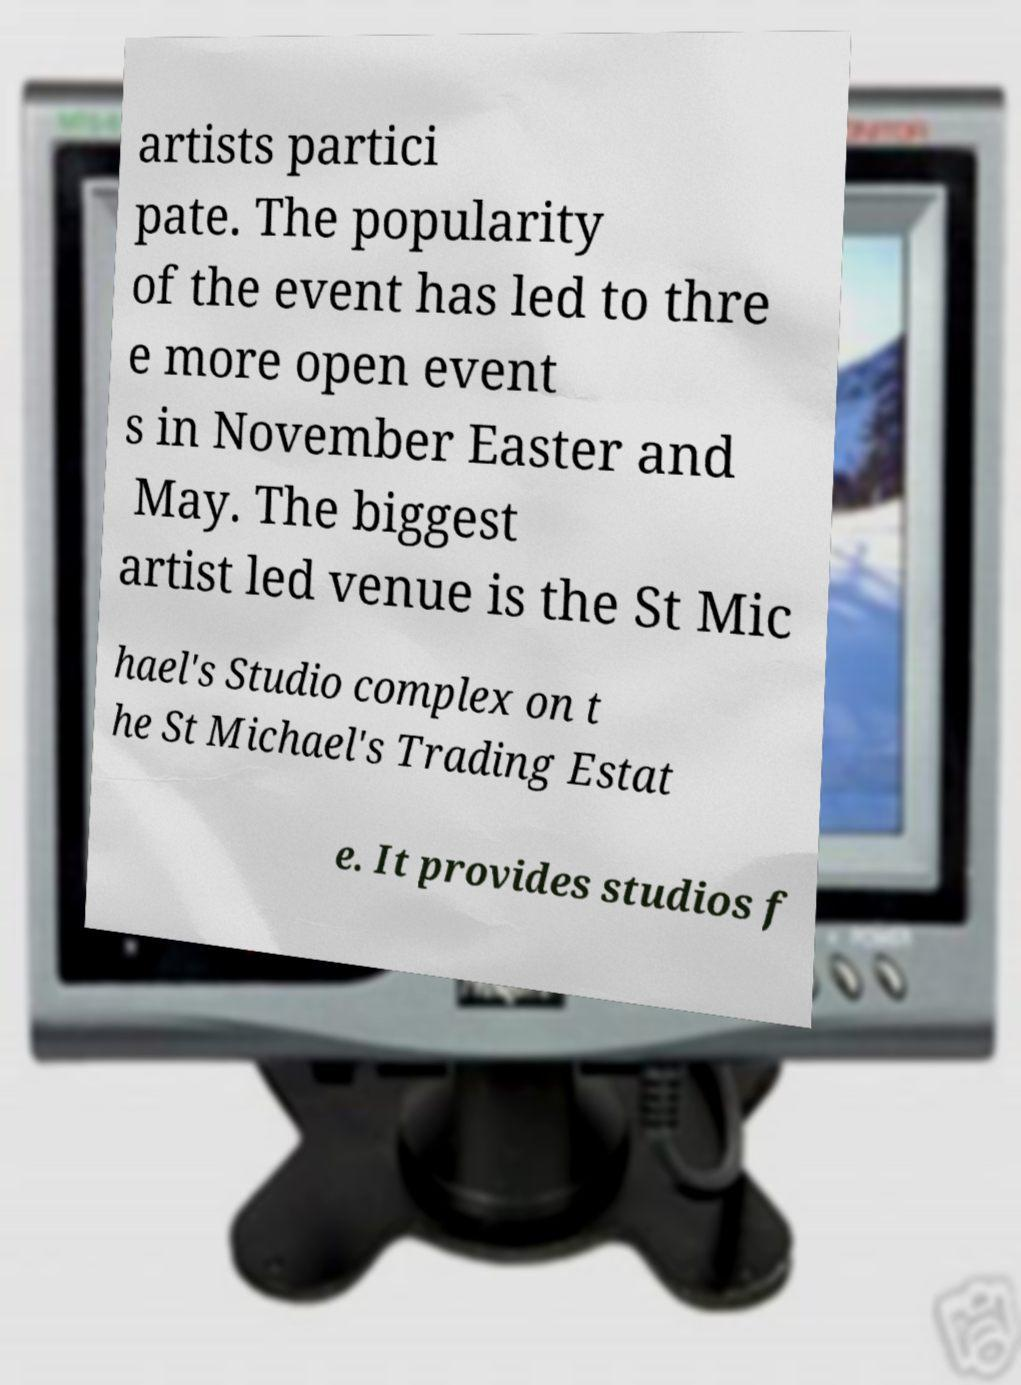Please read and relay the text visible in this image. What does it say? artists partici pate. The popularity of the event has led to thre e more open event s in November Easter and May. The biggest artist led venue is the St Mic hael's Studio complex on t he St Michael's Trading Estat e. It provides studios f 